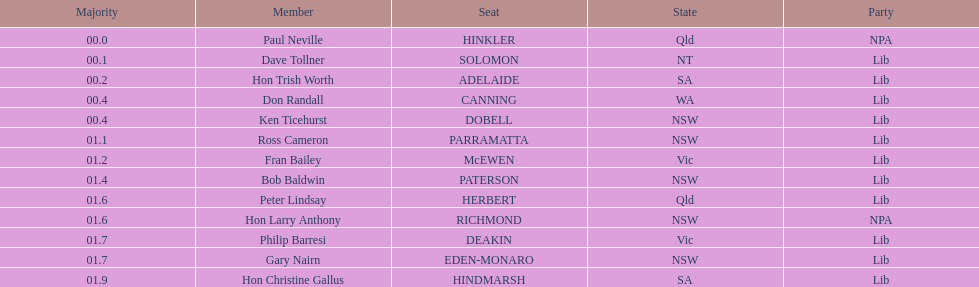What member comes next after hon trish worth? Don Randall. 